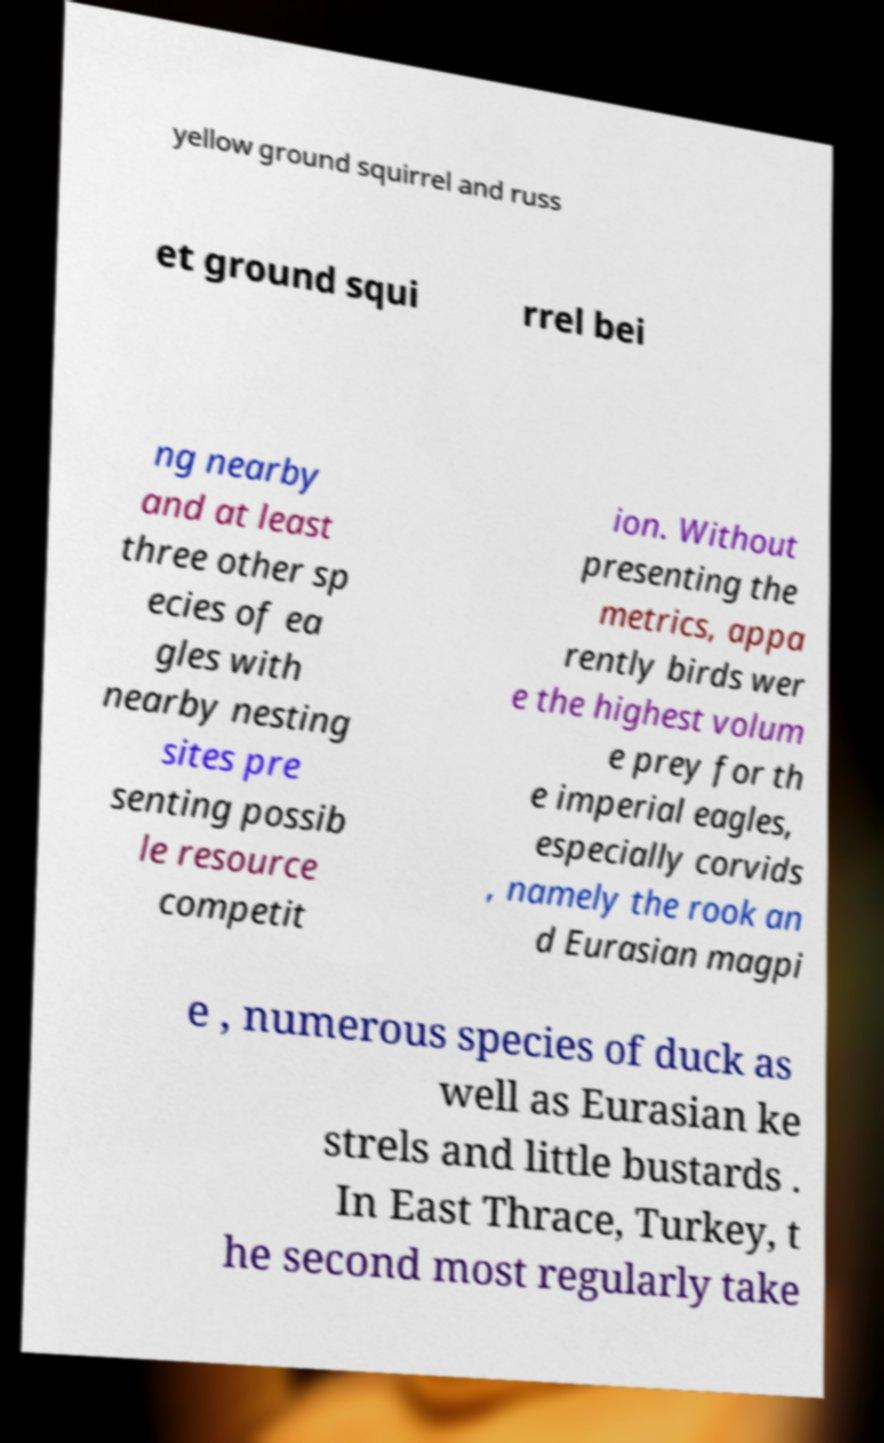Could you extract and type out the text from this image? yellow ground squirrel and russ et ground squi rrel bei ng nearby and at least three other sp ecies of ea gles with nearby nesting sites pre senting possib le resource competit ion. Without presenting the metrics, appa rently birds wer e the highest volum e prey for th e imperial eagles, especially corvids , namely the rook an d Eurasian magpi e , numerous species of duck as well as Eurasian ke strels and little bustards . In East Thrace, Turkey, t he second most regularly take 